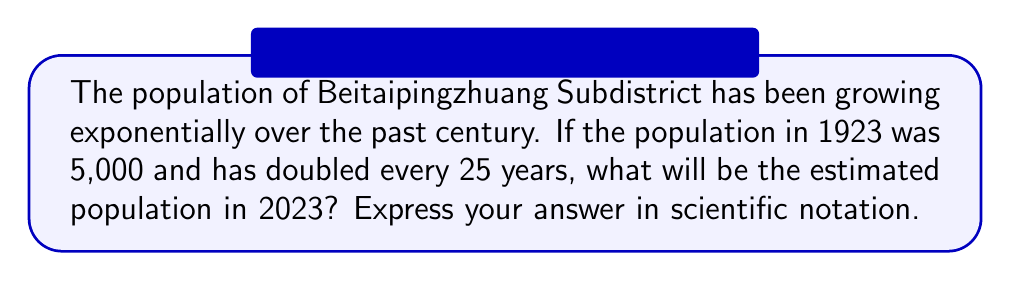Show me your answer to this math problem. Let's approach this step-by-step:

1) First, we need to determine how many 25-year periods have passed from 1923 to 2023.
   $2023 - 1923 = 100$ years
   $100 \div 25 = 4$ periods

2) The population doubles every period, so we can express this as:
   $\text{Population} = 5000 \times 2^4$

3) Let's calculate this:
   $5000 \times 2^4 = 5000 \times 16 = 80,000$

4) To express this in scientific notation:
   $80,000 = 8.0 \times 10^4$

This growth pattern aligns with the historical development of Beitaipingzhuang Subdistrict over the past century, reflecting its transformation from a small village to a bustling urban area.
Answer: $8.0 \times 10^4$ 